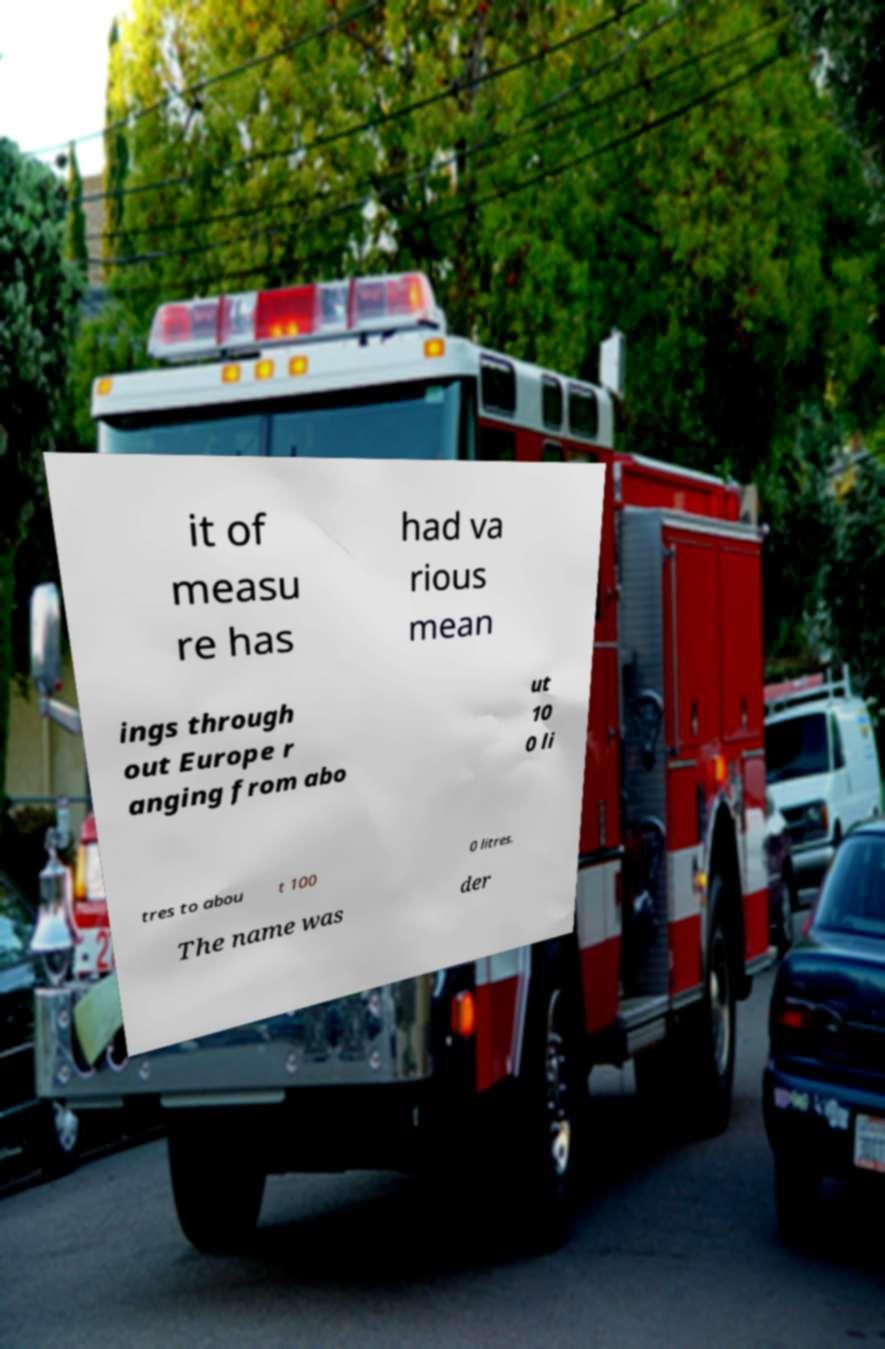Please read and relay the text visible in this image. What does it say? it of measu re has had va rious mean ings through out Europe r anging from abo ut 10 0 li tres to abou t 100 0 litres. The name was der 